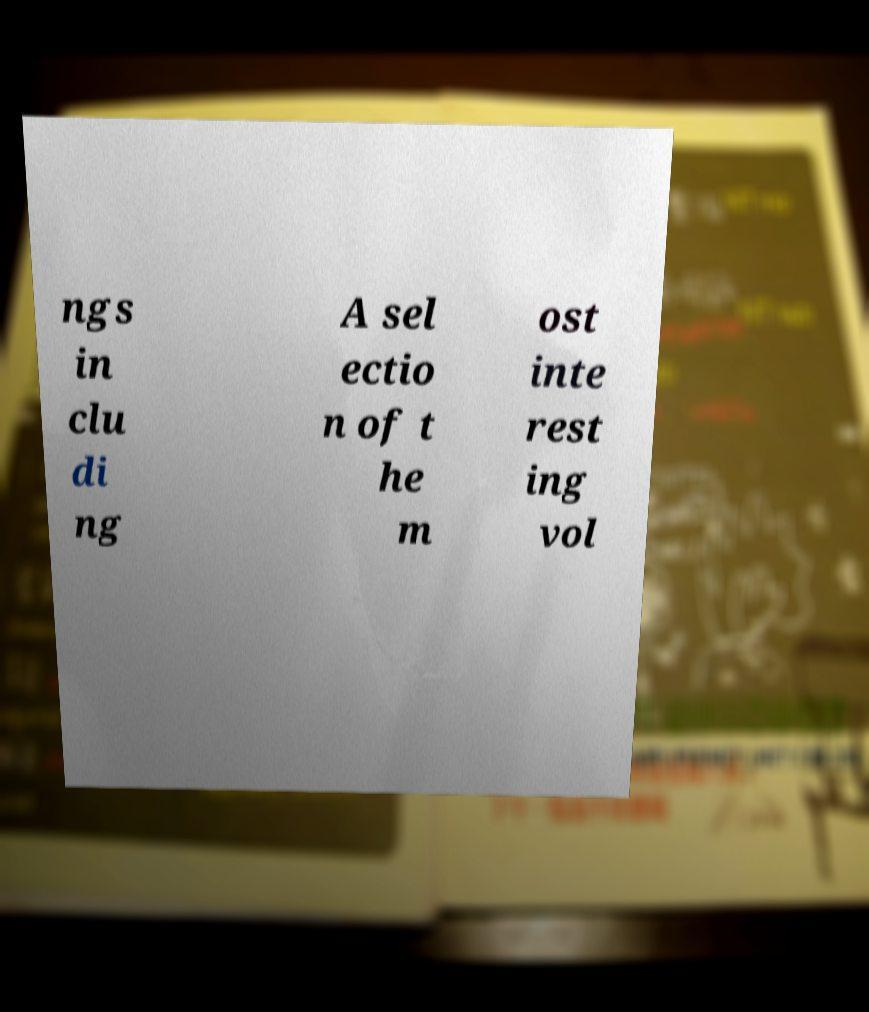There's text embedded in this image that I need extracted. Can you transcribe it verbatim? ngs in clu di ng A sel ectio n of t he m ost inte rest ing vol 